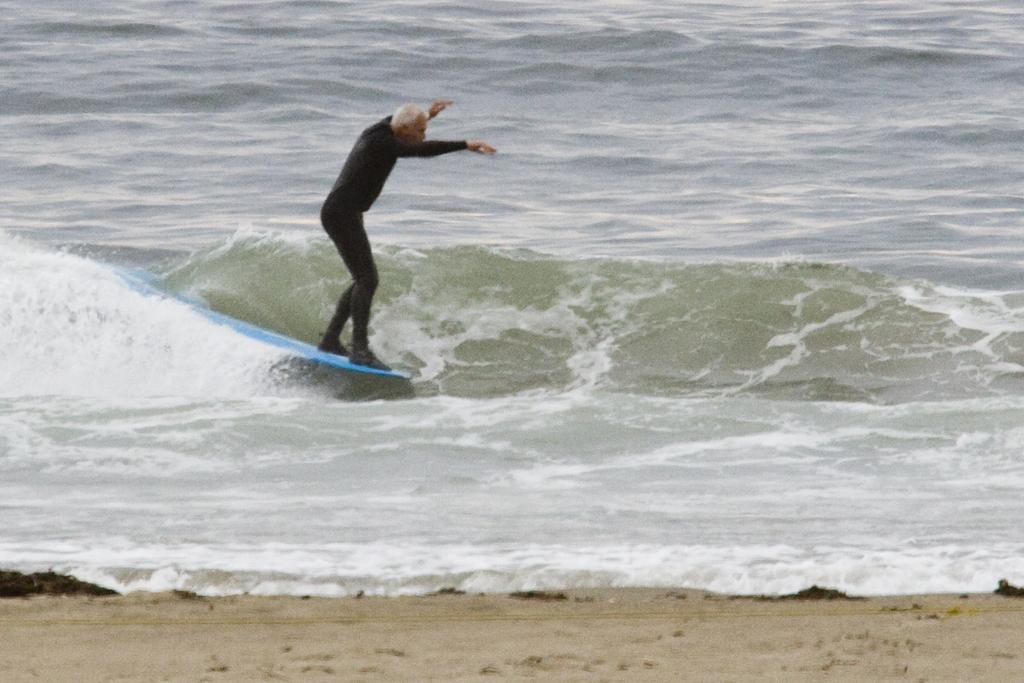What is the main subject in the foreground of the image? There is a man in the foreground of the image. What is the man doing in the image? The man is surfing on the water. What type of terrain can be seen at the bottom of the image? There is sand visible at the bottom of the image. What type of furniture can be seen in the image? There is no furniture present in the image; it features a man surfing on the water. What emotion is the man expressing while surfing in the image? The image does not show the man's emotions, so it cannot be determined from the image. 